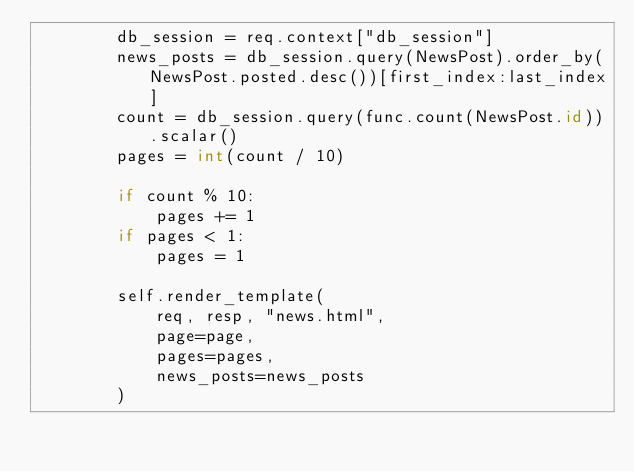<code> <loc_0><loc_0><loc_500><loc_500><_Python_>        db_session = req.context["db_session"]
        news_posts = db_session.query(NewsPost).order_by(NewsPost.posted.desc())[first_index:last_index]
        count = db_session.query(func.count(NewsPost.id)).scalar()
        pages = int(count / 10)

        if count % 10:
            pages += 1
        if pages < 1:
            pages = 1

        self.render_template(
            req, resp, "news.html",
            page=page,
            pages=pages,
            news_posts=news_posts
        )
</code> 